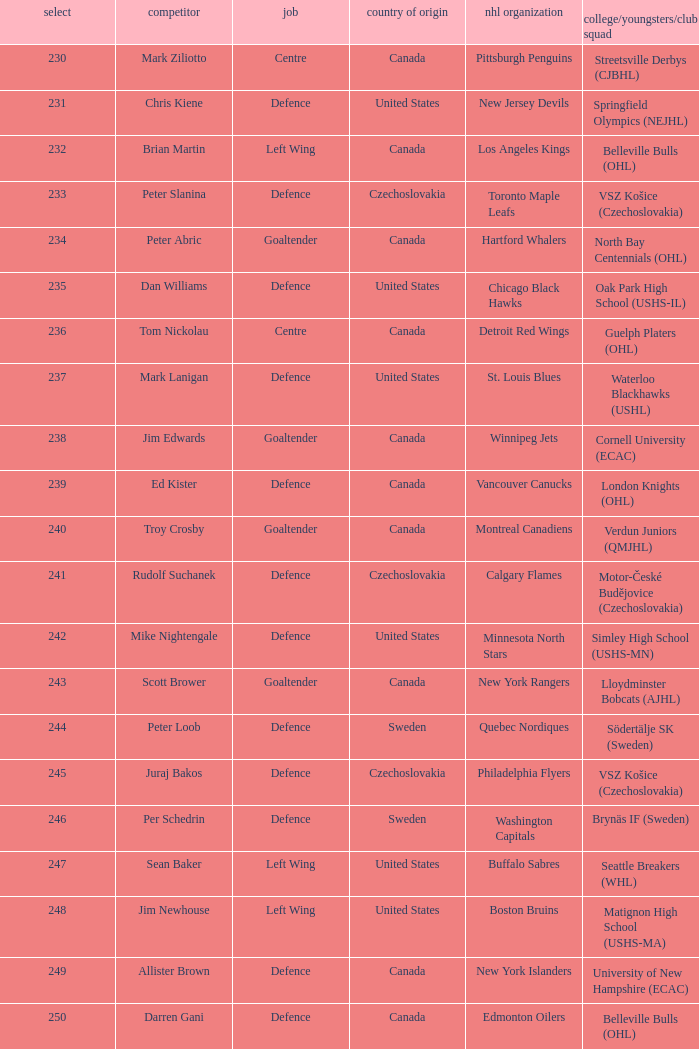Give me the full table as a dictionary. {'header': ['select', 'competitor', 'job', 'country of origin', 'nhl organization', 'college/youngsters/club squad'], 'rows': [['230', 'Mark Ziliotto', 'Centre', 'Canada', 'Pittsburgh Penguins', 'Streetsville Derbys (CJBHL)'], ['231', 'Chris Kiene', 'Defence', 'United States', 'New Jersey Devils', 'Springfield Olympics (NEJHL)'], ['232', 'Brian Martin', 'Left Wing', 'Canada', 'Los Angeles Kings', 'Belleville Bulls (OHL)'], ['233', 'Peter Slanina', 'Defence', 'Czechoslovakia', 'Toronto Maple Leafs', 'VSZ Košice (Czechoslovakia)'], ['234', 'Peter Abric', 'Goaltender', 'Canada', 'Hartford Whalers', 'North Bay Centennials (OHL)'], ['235', 'Dan Williams', 'Defence', 'United States', 'Chicago Black Hawks', 'Oak Park High School (USHS-IL)'], ['236', 'Tom Nickolau', 'Centre', 'Canada', 'Detroit Red Wings', 'Guelph Platers (OHL)'], ['237', 'Mark Lanigan', 'Defence', 'United States', 'St. Louis Blues', 'Waterloo Blackhawks (USHL)'], ['238', 'Jim Edwards', 'Goaltender', 'Canada', 'Winnipeg Jets', 'Cornell University (ECAC)'], ['239', 'Ed Kister', 'Defence', 'Canada', 'Vancouver Canucks', 'London Knights (OHL)'], ['240', 'Troy Crosby', 'Goaltender', 'Canada', 'Montreal Canadiens', 'Verdun Juniors (QMJHL)'], ['241', 'Rudolf Suchanek', 'Defence', 'Czechoslovakia', 'Calgary Flames', 'Motor-České Budějovice (Czechoslovakia)'], ['242', 'Mike Nightengale', 'Defence', 'United States', 'Minnesota North Stars', 'Simley High School (USHS-MN)'], ['243', 'Scott Brower', 'Goaltender', 'Canada', 'New York Rangers', 'Lloydminster Bobcats (AJHL)'], ['244', 'Peter Loob', 'Defence', 'Sweden', 'Quebec Nordiques', 'Södertälje SK (Sweden)'], ['245', 'Juraj Bakos', 'Defence', 'Czechoslovakia', 'Philadelphia Flyers', 'VSZ Košice (Czechoslovakia)'], ['246', 'Per Schedrin', 'Defence', 'Sweden', 'Washington Capitals', 'Brynäs IF (Sweden)'], ['247', 'Sean Baker', 'Left Wing', 'United States', 'Buffalo Sabres', 'Seattle Breakers (WHL)'], ['248', 'Jim Newhouse', 'Left Wing', 'United States', 'Boston Bruins', 'Matignon High School (USHS-MA)'], ['249', 'Allister Brown', 'Defence', 'Canada', 'New York Islanders', 'University of New Hampshire (ECAC)'], ['250', 'Darren Gani', 'Defence', 'Canada', 'Edmonton Oilers', 'Belleville Bulls (OHL)']]} To which organziation does the  winnipeg jets belong to? Cornell University (ECAC). 